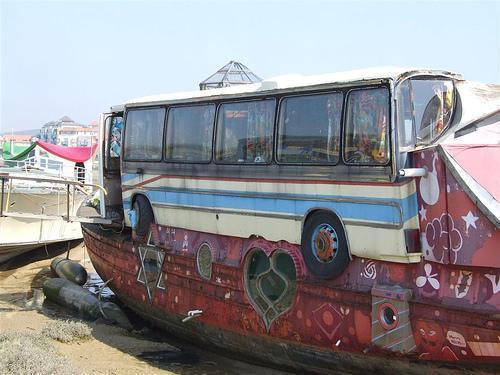What do people most likely do in the structure?
Select the accurate answer and provide explanation: 'Answer: answer
Rationale: rationale.'
Options: Sleep, vote, run, swim. Answer: sleep.
Rationale: A person has somehow made boat into a house and has curtains for privacy. 